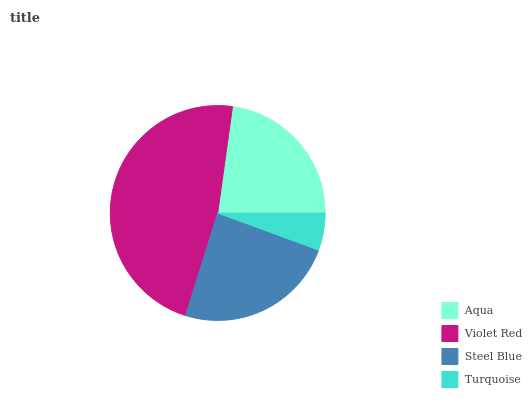Is Turquoise the minimum?
Answer yes or no. Yes. Is Violet Red the maximum?
Answer yes or no. Yes. Is Steel Blue the minimum?
Answer yes or no. No. Is Steel Blue the maximum?
Answer yes or no. No. Is Violet Red greater than Steel Blue?
Answer yes or no. Yes. Is Steel Blue less than Violet Red?
Answer yes or no. Yes. Is Steel Blue greater than Violet Red?
Answer yes or no. No. Is Violet Red less than Steel Blue?
Answer yes or no. No. Is Steel Blue the high median?
Answer yes or no. Yes. Is Aqua the low median?
Answer yes or no. Yes. Is Turquoise the high median?
Answer yes or no. No. Is Violet Red the low median?
Answer yes or no. No. 